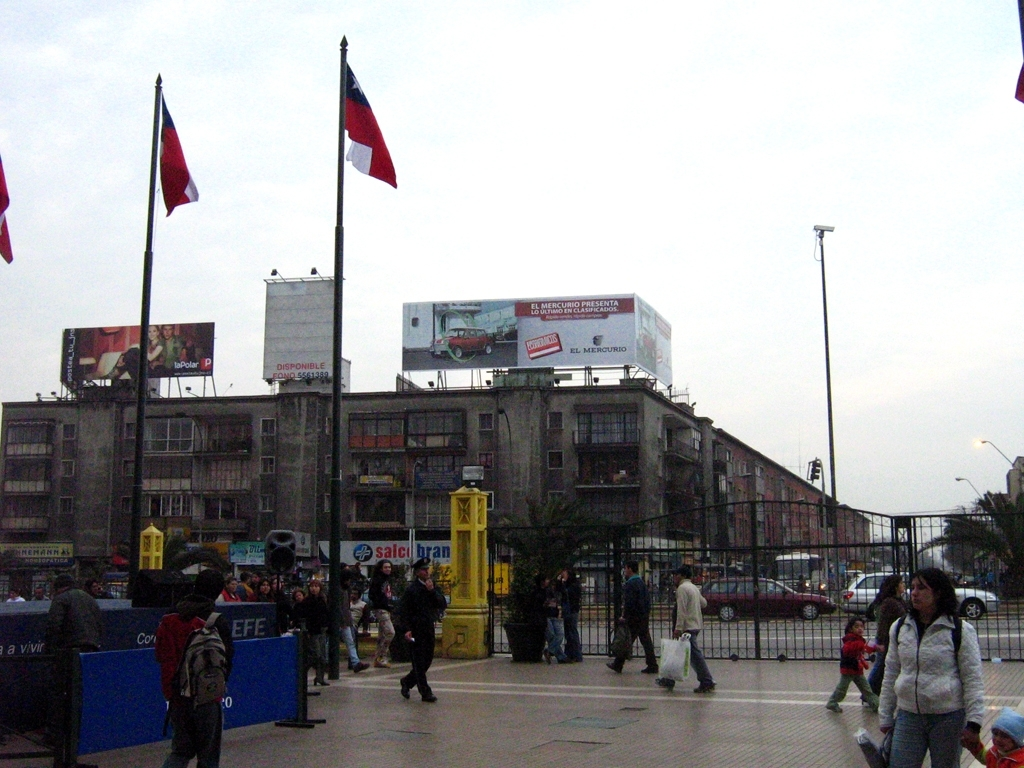What activities can be observed in this image? The image portrays an urban environment with pedestrians walking, some carrying bags that indicate they might be shopping or returning from errands. There are flags displayed, possibly suggesting a national holiday or a patriotic display, and billboards further hint at commercial activity in the area. 